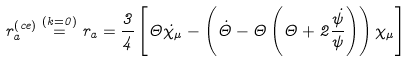Convert formula to latex. <formula><loc_0><loc_0><loc_500><loc_500>r _ { a } ^ { \left ( c e \right ) } \stackrel { \left ( k = 0 \right ) } { = } r _ { a } = \frac { 3 } { 4 } \left [ \Theta \dot { \chi } _ { \mu } - \left ( \dot { \Theta } - \Theta \left ( \Theta + 2 \frac { \dot { \psi } } { \psi } \right ) \right ) \chi _ { \mu } \right ]</formula> 